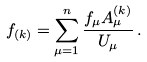Convert formula to latex. <formula><loc_0><loc_0><loc_500><loc_500>f _ { ( k ) } = \sum _ { \mu = 1 } ^ { n } \frac { f _ { \mu } A _ { \mu } ^ { ( k ) } } { U _ { \mu } } \, .</formula> 